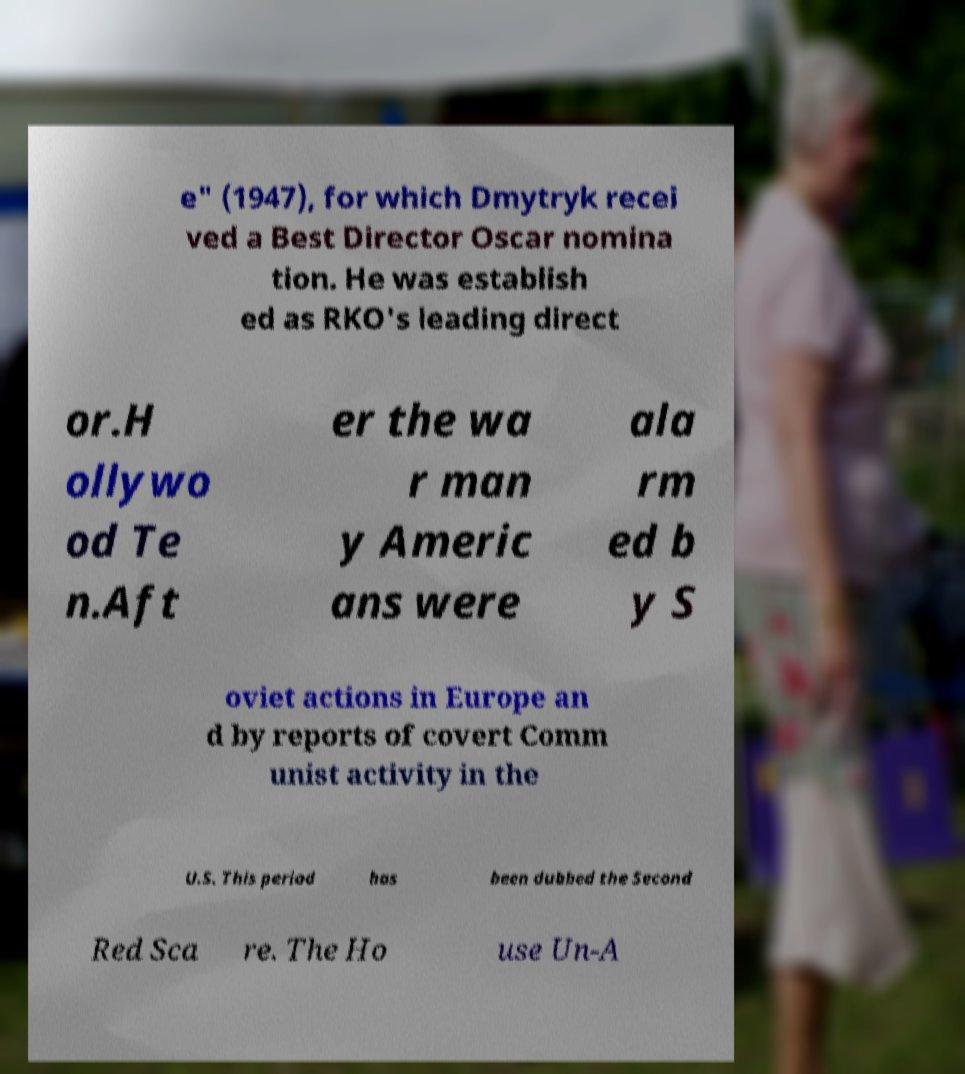Please identify and transcribe the text found in this image. e" (1947), for which Dmytryk recei ved a Best Director Oscar nomina tion. He was establish ed as RKO's leading direct or.H ollywo od Te n.Aft er the wa r man y Americ ans were ala rm ed b y S oviet actions in Europe an d by reports of covert Comm unist activity in the U.S. This period has been dubbed the Second Red Sca re. The Ho use Un-A 